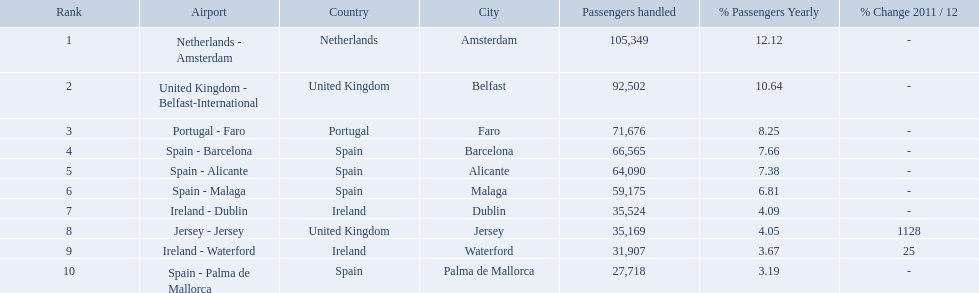Which airports had passengers going through london southend airport? Netherlands - Amsterdam, United Kingdom - Belfast-International, Portugal - Faro, Spain - Barcelona, Spain - Alicante, Spain - Malaga, Ireland - Dublin, Jersey - Jersey, Ireland - Waterford, Spain - Palma de Mallorca. Of those airports, which airport had the least amount of passengers going through london southend airport? Spain - Palma de Mallorca. What are all of the destinations out of the london southend airport? Netherlands - Amsterdam, United Kingdom - Belfast-International, Portugal - Faro, Spain - Barcelona, Spain - Alicante, Spain - Malaga, Ireland - Dublin, Jersey - Jersey, Ireland - Waterford, Spain - Palma de Mallorca. How many passengers has each destination handled? 105,349, 92,502, 71,676, 66,565, 64,090, 59,175, 35,524, 35,169, 31,907, 27,718. And of those, which airport handled the fewest passengers? Spain - Palma de Mallorca. What are all the passengers handled values for london southend airport? 105,349, 92,502, 71,676, 66,565, 64,090, 59,175, 35,524, 35,169, 31,907, 27,718. Which are 30,000 or less? 27,718. What airport is this for? Spain - Palma de Mallorca. What are the numbers of passengers handled along the different routes in the airport? 105,349, 92,502, 71,676, 66,565, 64,090, 59,175, 35,524, 35,169, 31,907, 27,718. Of these routes, which handles less than 30,000 passengers? Spain - Palma de Mallorca. Name all the london southend airports that did not list a change in 2001/12. Netherlands - Amsterdam, United Kingdom - Belfast-International, Portugal - Faro, Spain - Barcelona, Spain - Alicante, Spain - Malaga, Ireland - Dublin, Spain - Palma de Mallorca. What unchanged percentage airports from 2011/12 handled less then 50,000 passengers? Ireland - Dublin, Spain - Palma de Mallorca. What unchanged percentage airport from 2011/12 handled less then 50,000 passengers is the closest to the equator? Spain - Palma de Mallorca. What are all of the airports? Netherlands - Amsterdam, United Kingdom - Belfast-International, Portugal - Faro, Spain - Barcelona, Spain - Alicante, Spain - Malaga, Ireland - Dublin, Jersey - Jersey, Ireland - Waterford, Spain - Palma de Mallorca. How many passengers have they handled? 105,349, 92,502, 71,676, 66,565, 64,090, 59,175, 35,524, 35,169, 31,907, 27,718. And which airport has handled the most passengers? Netherlands - Amsterdam. What are the 10 busiest routes to and from london southend airport? Netherlands - Amsterdam, United Kingdom - Belfast-International, Portugal - Faro, Spain - Barcelona, Spain - Alicante, Spain - Malaga, Ireland - Dublin, Jersey - Jersey, Ireland - Waterford, Spain - Palma de Mallorca. Of these, which airport is in portugal? Portugal - Faro. What are all of the routes out of the london southend airport? Netherlands - Amsterdam, United Kingdom - Belfast-International, Portugal - Faro, Spain - Barcelona, Spain - Alicante, Spain - Malaga, Ireland - Dublin, Jersey - Jersey, Ireland - Waterford, Spain - Palma de Mallorca. How many passengers have traveled to each destination? 105,349, 92,502, 71,676, 66,565, 64,090, 59,175, 35,524, 35,169, 31,907, 27,718. And which destination has been the most popular to passengers? Netherlands - Amsterdam. 